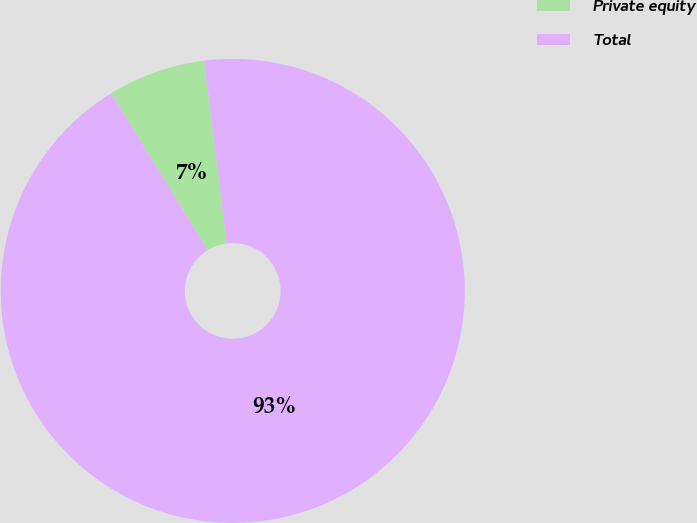Convert chart. <chart><loc_0><loc_0><loc_500><loc_500><pie_chart><fcel>Private equity<fcel>Total<nl><fcel>6.81%<fcel>93.19%<nl></chart> 